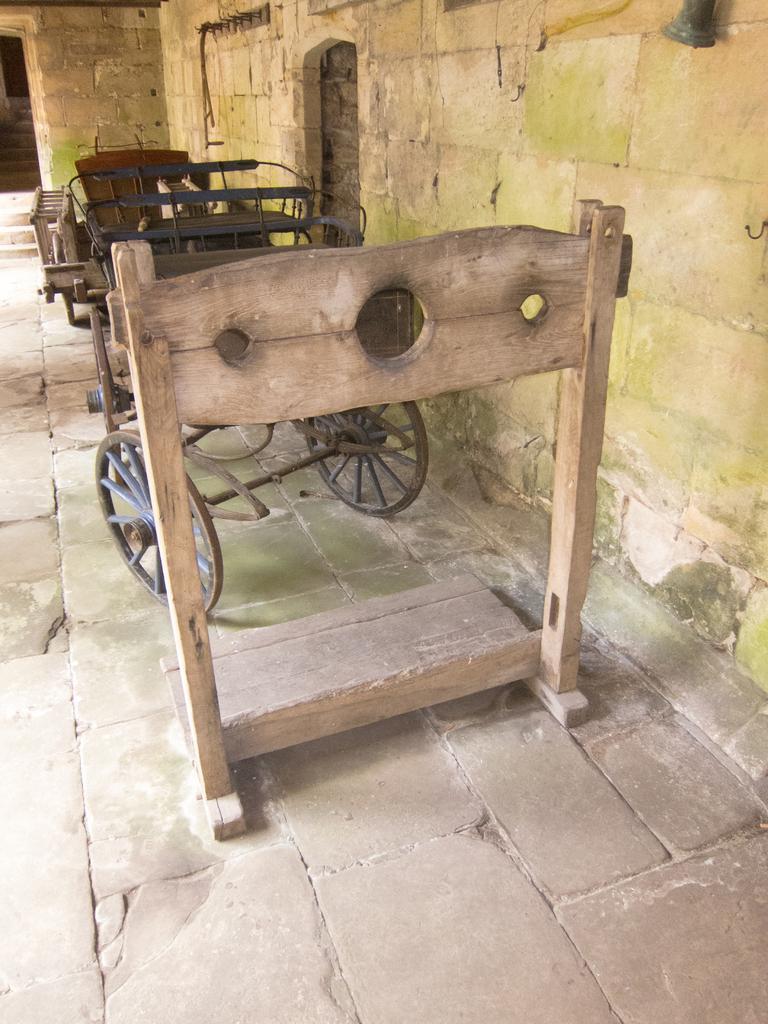In one or two sentences, can you explain what this image depicts? In this picture it looks like a wooden stand and an iron cart kept in a place made of stone walls and floor. 